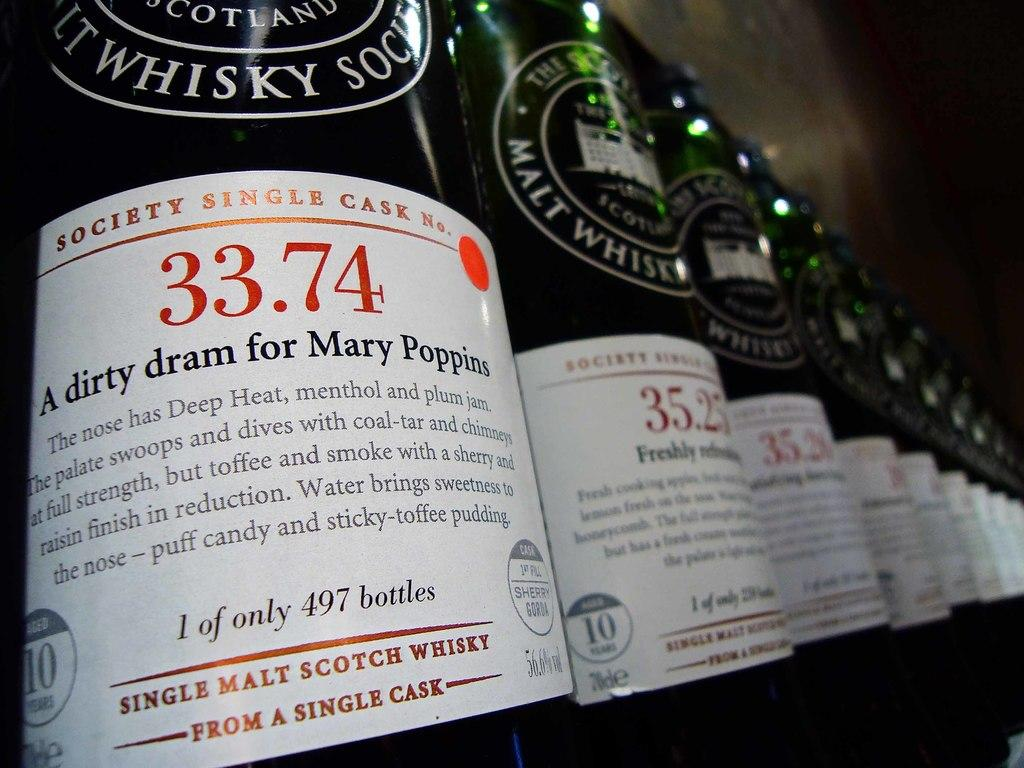<image>
Present a compact description of the photo's key features. A bottle with a white label has the number 33.74 on it. 